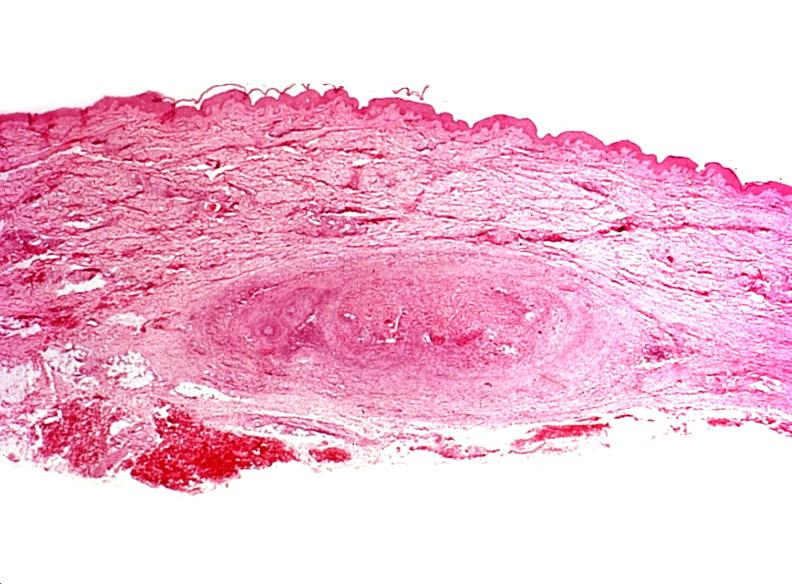where is this?
Answer the question using a single word or phrase. Skin 